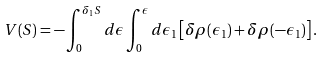Convert formula to latex. <formula><loc_0><loc_0><loc_500><loc_500>V ( S ) = - \int ^ { \delta _ { 1 } S } _ { 0 } d \epsilon \int ^ { \epsilon } _ { 0 } d \epsilon _ { 1 } \left [ \delta \rho ( \epsilon _ { 1 } ) + \delta \rho ( - \epsilon _ { 1 } ) \right ] .</formula> 